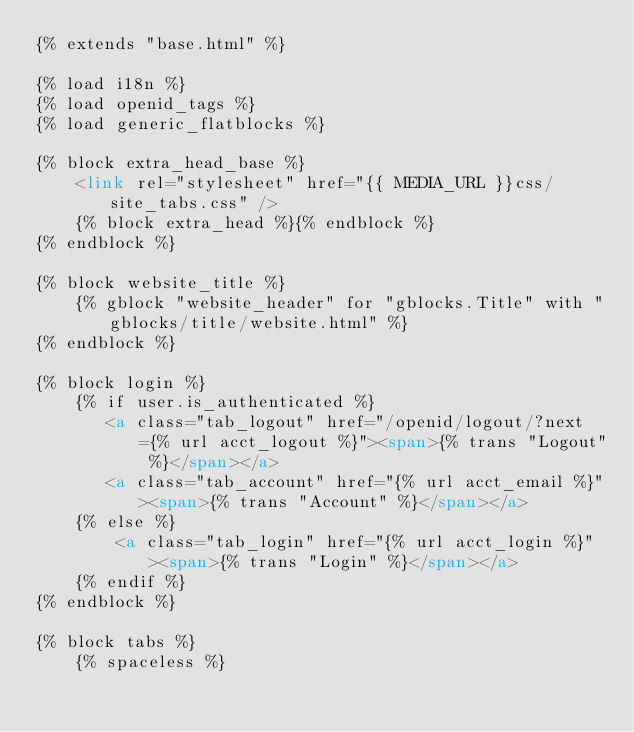<code> <loc_0><loc_0><loc_500><loc_500><_HTML_>{% extends "base.html" %}

{% load i18n %}
{% load openid_tags %}
{% load generic_flatblocks %}

{% block extra_head_base %}
    <link rel="stylesheet" href="{{ MEDIA_URL }}css/site_tabs.css" />
    {% block extra_head %}{% endblock %}
{% endblock %}

{% block website_title %}
    {% gblock "website_header" for "gblocks.Title" with "gblocks/title/website.html" %}
{% endblock %}

{% block login %}
    {% if user.is_authenticated %}
       <a class="tab_logout" href="/openid/logout/?next={% url acct_logout %}"><span>{% trans "Logout" %}</span></a>
       <a class="tab_account" href="{% url acct_email %}"><span>{% trans "Account" %}</span></a>
    {% else %}
        <a class="tab_login" href="{% url acct_login %}"><span>{% trans "Login" %}</span></a>
    {% endif %}
{% endblock %}

{% block tabs %}
    {% spaceless %}</code> 